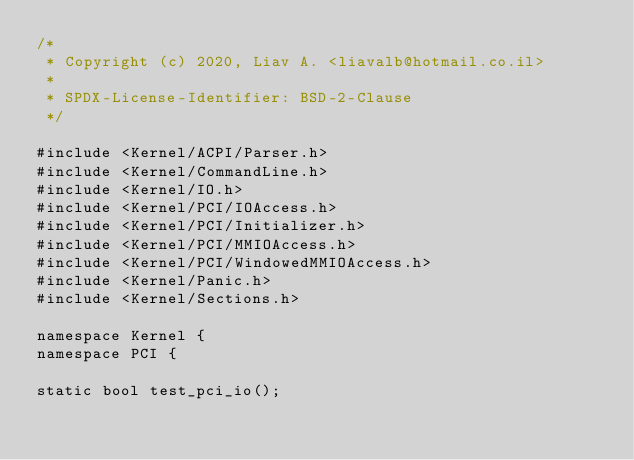Convert code to text. <code><loc_0><loc_0><loc_500><loc_500><_C++_>/*
 * Copyright (c) 2020, Liav A. <liavalb@hotmail.co.il>
 *
 * SPDX-License-Identifier: BSD-2-Clause
 */

#include <Kernel/ACPI/Parser.h>
#include <Kernel/CommandLine.h>
#include <Kernel/IO.h>
#include <Kernel/PCI/IOAccess.h>
#include <Kernel/PCI/Initializer.h>
#include <Kernel/PCI/MMIOAccess.h>
#include <Kernel/PCI/WindowedMMIOAccess.h>
#include <Kernel/Panic.h>
#include <Kernel/Sections.h>

namespace Kernel {
namespace PCI {

static bool test_pci_io();
</code> 